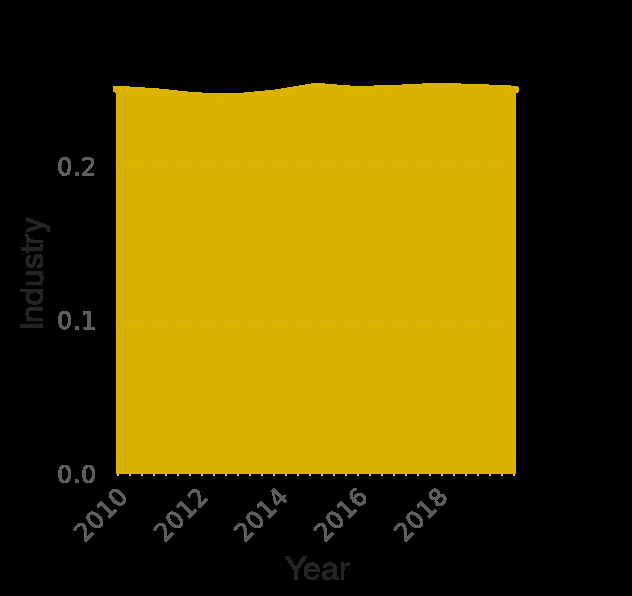<image>
please summary the statistics and relations of the chart Between 2010 and 2020 employment in the industry sector of South Korea has remained fairly static at around 0.25. The fall and rise between 2010 and 2015 is so small as to be impossible to put a number on in the context of this representation. Has there been any significant fluctuation in employment in the industry sector of South Korea over the past 10 years? No, the employment in the industry sector of South Korea has remained fairly static with no significant fluctuations. What is the title of the area graph? The title of the area graph is "South Korea: Distribution of employment by economic sector from 2010 to 2020." 